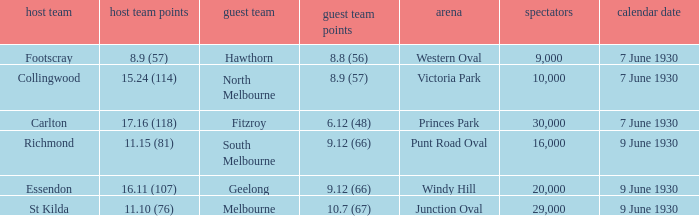What is the average crowd size when North Melbourne is the away team? 10000.0. 